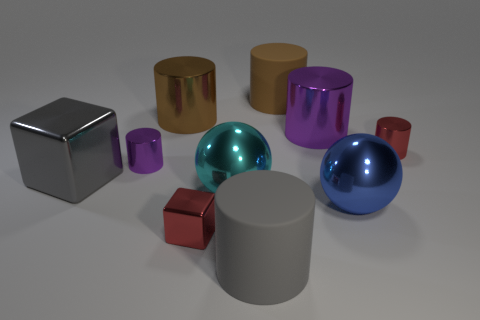Subtract all red cylinders. How many cylinders are left? 5 Subtract all purple cylinders. How many cylinders are left? 4 Subtract all blocks. How many objects are left? 8 Subtract 1 gray cubes. How many objects are left? 9 Subtract 5 cylinders. How many cylinders are left? 1 Subtract all red balls. Subtract all gray cylinders. How many balls are left? 2 Subtract all yellow cylinders. How many blue spheres are left? 1 Subtract all rubber objects. Subtract all small purple cylinders. How many objects are left? 7 Add 4 small blocks. How many small blocks are left? 5 Add 8 tiny purple metal things. How many tiny purple metal things exist? 9 